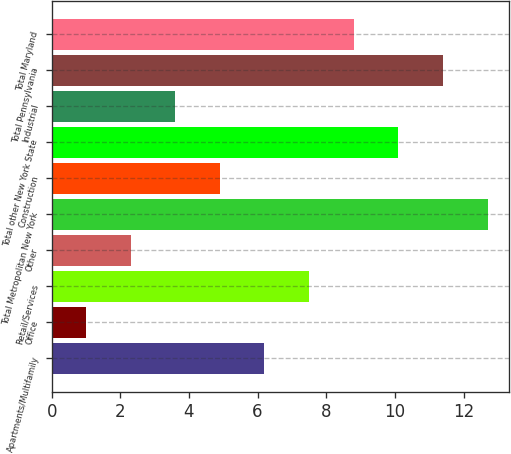<chart> <loc_0><loc_0><loc_500><loc_500><bar_chart><fcel>Apartments/Multifamily<fcel>Office<fcel>Retail/Services<fcel>Other<fcel>Total Metropolitan New York<fcel>Construction<fcel>Total other New York State<fcel>Industrial<fcel>Total Pennsylvania<fcel>Total Maryland<nl><fcel>6.2<fcel>1<fcel>7.5<fcel>2.3<fcel>12.7<fcel>4.9<fcel>10.1<fcel>3.6<fcel>11.4<fcel>8.8<nl></chart> 